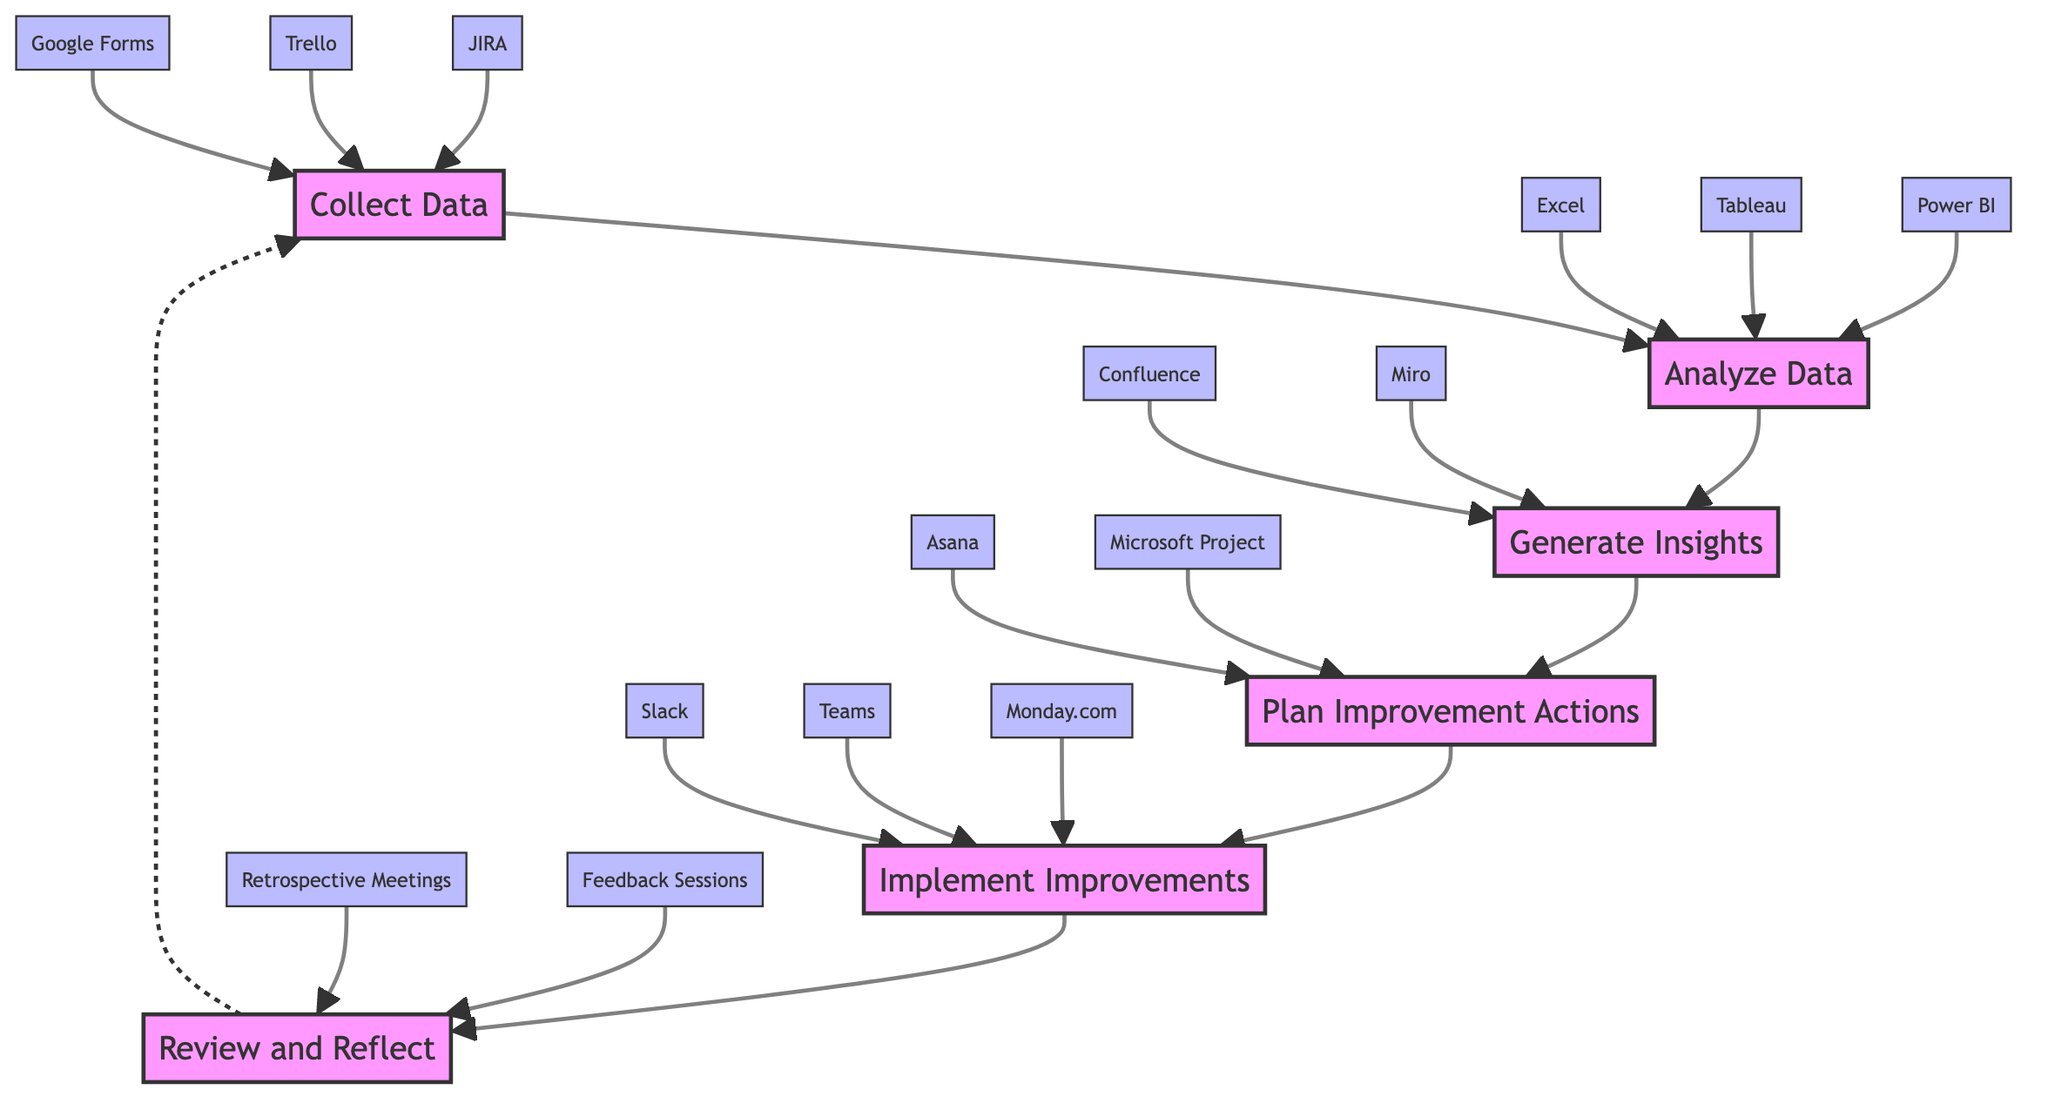What is the first step in the feedback loop? The first step in the feedback loop, as per the diagram, is "Collect Data." It represents the starting point where team members gather performance metrics and feedback.
Answer: Collect Data Who is responsible for analyzing the data? According to the diagram, the "Data Analyst" is responsible for the step of "Analyze Data," where they evaluate the collected data for trends and improvement areas.
Answer: Data Analyst What tools are used in the implementation step? The implementation step involves tools listed under "Implement Improvements," specifically "Slack," "Teams," and "Monday.com." These are collaboration platforms utilized by team members during implementation.
Answer: Slack, Teams, Monday.com Which step follows "Generate Insights"? The step that directly follows "Generate Insights" in the feedback loop is "Plan Improvement Actions." This indicates the sequential nature of progressing from analyzing to planning based on insights gained.
Answer: Plan Improvement Actions How many total steps are in this feedback loop? The diagram outlines a total of six distinct steps from "Collect Data" to "Review and Reflect," showing the complete cycle of continuous improvement in project management practices.
Answer: Six What is the purpose of the "Review and Reflect" step? The "Review and Reflect" step assesses the outcomes of implemented improvements. It focuses on evaluating their impact and making necessary adjustments to future plans based on this evaluation.
Answer: To assess impact and adjust plans Which tools are specifically used to collect data? The tools used in the "Collect Data" step include "JIRA," "Trello," and "Google Forms." These are various platforms that facilitate gathering performance metrics and team feedback.
Answer: JIRA, Trello, Google Forms What indicates that the process is a loop? The dotted line from "Review and Reflect" back to "Collect Data" suggests a continuous loop, indicating that after reviewing, the process returns to data collection for ongoing improvement.
Answer: Dotted line from Review and Reflect to Collect Data 